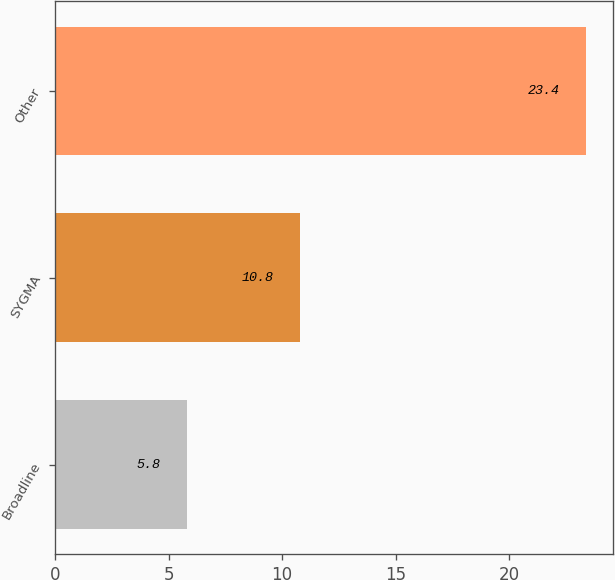Convert chart to OTSL. <chart><loc_0><loc_0><loc_500><loc_500><bar_chart><fcel>Broadline<fcel>SYGMA<fcel>Other<nl><fcel>5.8<fcel>10.8<fcel>23.4<nl></chart> 